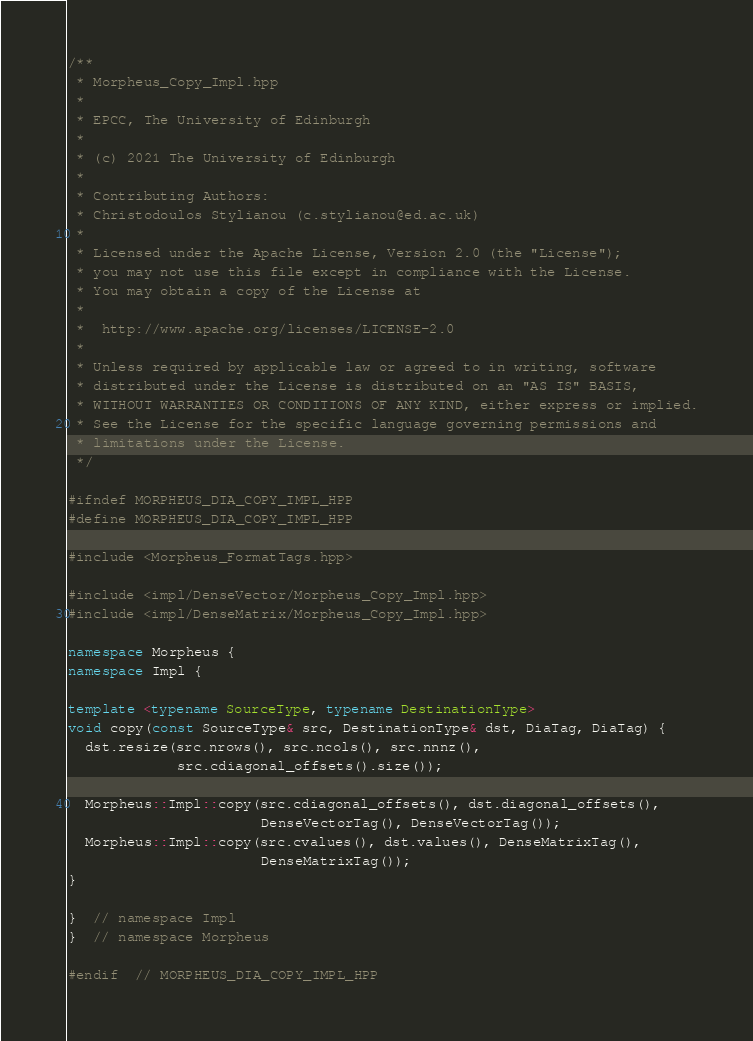Convert code to text. <code><loc_0><loc_0><loc_500><loc_500><_C++_>/**
 * Morpheus_Copy_Impl.hpp
 *
 * EPCC, The University of Edinburgh
 *
 * (c) 2021 The University of Edinburgh
 *
 * Contributing Authors:
 * Christodoulos Stylianou (c.stylianou@ed.ac.uk)
 *
 * Licensed under the Apache License, Version 2.0 (the "License");
 * you may not use this file except in compliance with the License.
 * You may obtain a copy of the License at
 *
 * 	http://www.apache.org/licenses/LICENSE-2.0
 *
 * Unless required by applicable law or agreed to in writing, software
 * distributed under the License is distributed on an "AS IS" BASIS,
 * WITHOUT WARRANTIES OR CONDITIONS OF ANY KIND, either express or implied.
 * See the License for the specific language governing permissions and
 * limitations under the License.
 */

#ifndef MORPHEUS_DIA_COPY_IMPL_HPP
#define MORPHEUS_DIA_COPY_IMPL_HPP

#include <Morpheus_FormatTags.hpp>

#include <impl/DenseVector/Morpheus_Copy_Impl.hpp>
#include <impl/DenseMatrix/Morpheus_Copy_Impl.hpp>

namespace Morpheus {
namespace Impl {

template <typename SourceType, typename DestinationType>
void copy(const SourceType& src, DestinationType& dst, DiaTag, DiaTag) {
  dst.resize(src.nrows(), src.ncols(), src.nnnz(),
             src.cdiagonal_offsets().size());

  Morpheus::Impl::copy(src.cdiagonal_offsets(), dst.diagonal_offsets(),
                       DenseVectorTag(), DenseVectorTag());
  Morpheus::Impl::copy(src.cvalues(), dst.values(), DenseMatrixTag(),
                       DenseMatrixTag());
}

}  // namespace Impl
}  // namespace Morpheus

#endif  // MORPHEUS_DIA_COPY_IMPL_HPP</code> 